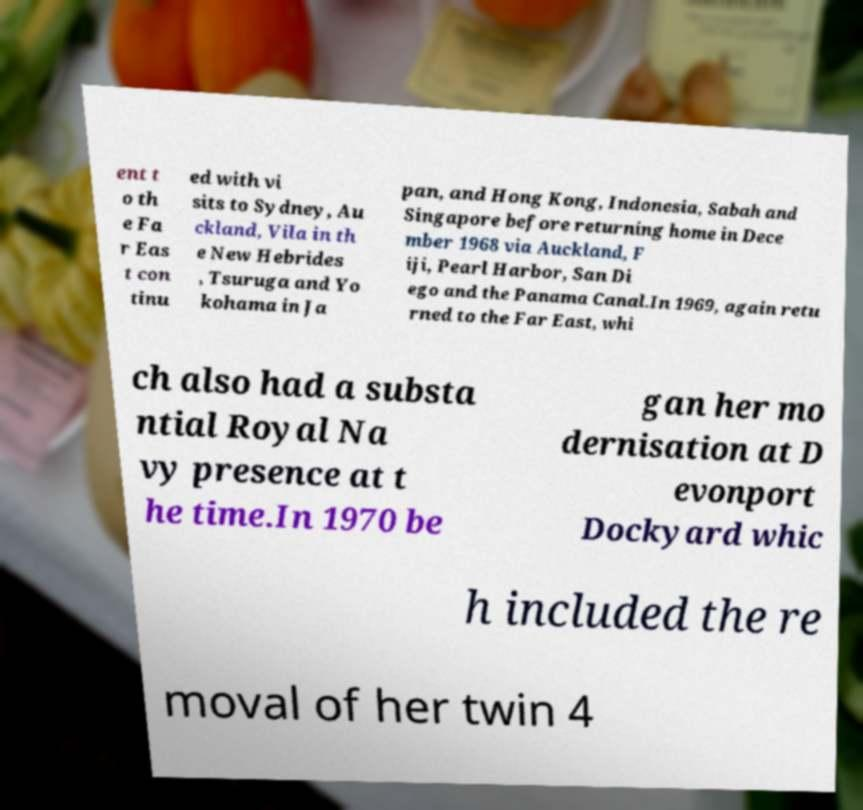Can you read and provide the text displayed in the image?This photo seems to have some interesting text. Can you extract and type it out for me? ent t o th e Fa r Eas t con tinu ed with vi sits to Sydney, Au ckland, Vila in th e New Hebrides , Tsuruga and Yo kohama in Ja pan, and Hong Kong, Indonesia, Sabah and Singapore before returning home in Dece mber 1968 via Auckland, F iji, Pearl Harbor, San Di ego and the Panama Canal.In 1969, again retu rned to the Far East, whi ch also had a substa ntial Royal Na vy presence at t he time.In 1970 be gan her mo dernisation at D evonport Dockyard whic h included the re moval of her twin 4 